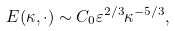Convert formula to latex. <formula><loc_0><loc_0><loc_500><loc_500>E ( \kappa , \cdot ) \sim C _ { 0 } \varepsilon ^ { 2 / 3 } \kappa ^ { - 5 / 3 } ,</formula> 